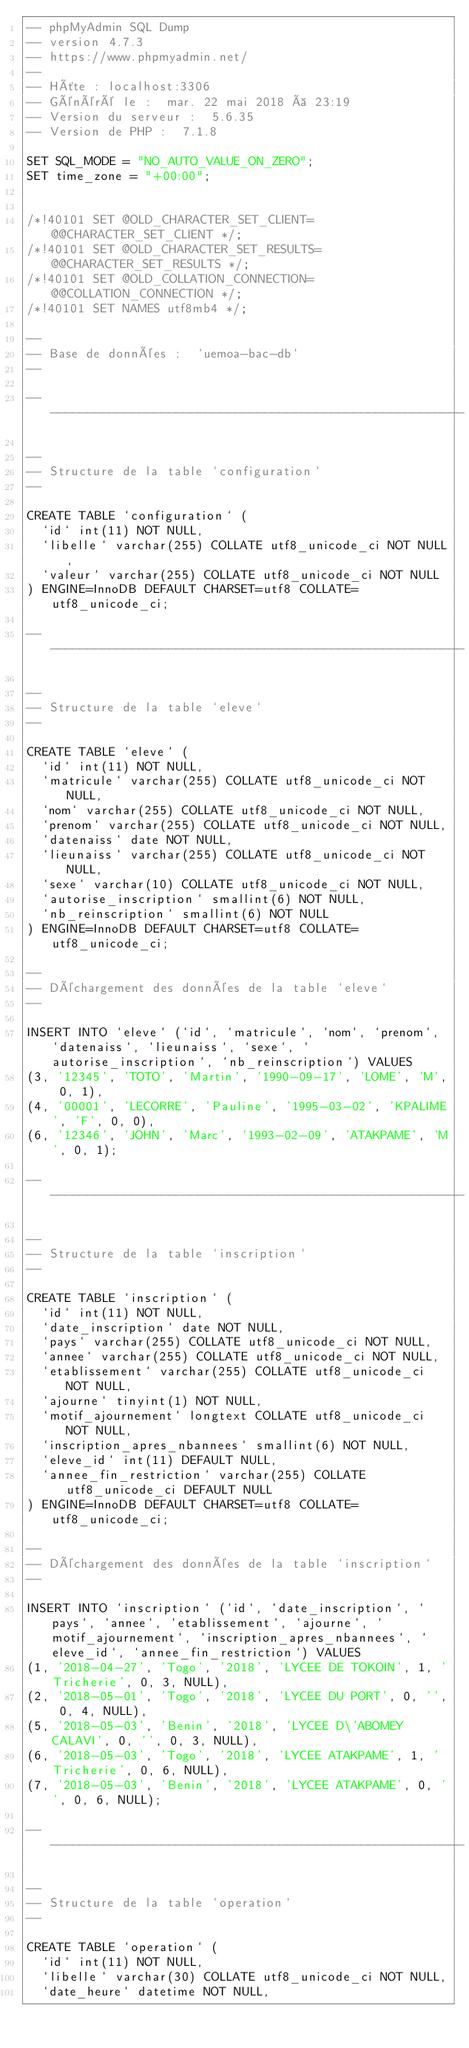<code> <loc_0><loc_0><loc_500><loc_500><_SQL_>-- phpMyAdmin SQL Dump
-- version 4.7.3
-- https://www.phpmyadmin.net/
--
-- Hôte : localhost:3306
-- Généré le :  mar. 22 mai 2018 à 23:19
-- Version du serveur :  5.6.35
-- Version de PHP :  7.1.8

SET SQL_MODE = "NO_AUTO_VALUE_ON_ZERO";
SET time_zone = "+00:00";


/*!40101 SET @OLD_CHARACTER_SET_CLIENT=@@CHARACTER_SET_CLIENT */;
/*!40101 SET @OLD_CHARACTER_SET_RESULTS=@@CHARACTER_SET_RESULTS */;
/*!40101 SET @OLD_COLLATION_CONNECTION=@@COLLATION_CONNECTION */;
/*!40101 SET NAMES utf8mb4 */;

--
-- Base de données :  `uemoa-bac-db`
--

-- --------------------------------------------------------

--
-- Structure de la table `configuration`
--

CREATE TABLE `configuration` (
  `id` int(11) NOT NULL,
  `libelle` varchar(255) COLLATE utf8_unicode_ci NOT NULL,
  `valeur` varchar(255) COLLATE utf8_unicode_ci NOT NULL
) ENGINE=InnoDB DEFAULT CHARSET=utf8 COLLATE=utf8_unicode_ci;

-- --------------------------------------------------------

--
-- Structure de la table `eleve`
--

CREATE TABLE `eleve` (
  `id` int(11) NOT NULL,
  `matricule` varchar(255) COLLATE utf8_unicode_ci NOT NULL,
  `nom` varchar(255) COLLATE utf8_unicode_ci NOT NULL,
  `prenom` varchar(255) COLLATE utf8_unicode_ci NOT NULL,
  `datenaiss` date NOT NULL,
  `lieunaiss` varchar(255) COLLATE utf8_unicode_ci NOT NULL,
  `sexe` varchar(10) COLLATE utf8_unicode_ci NOT NULL,
  `autorise_inscription` smallint(6) NOT NULL,
  `nb_reinscription` smallint(6) NOT NULL
) ENGINE=InnoDB DEFAULT CHARSET=utf8 COLLATE=utf8_unicode_ci;

--
-- Déchargement des données de la table `eleve`
--

INSERT INTO `eleve` (`id`, `matricule`, `nom`, `prenom`, `datenaiss`, `lieunaiss`, `sexe`, `autorise_inscription`, `nb_reinscription`) VALUES
(3, '12345', 'TOTO', 'Martin', '1990-09-17', 'LOME', 'M', 0, 1),
(4, '00001', 'LECORRE', 'Pauline', '1995-03-02', 'KPALIME', 'F', 0, 0),
(6, '12346', 'JOHN', 'Marc', '1993-02-09', 'ATAKPAME', 'M', 0, 1);

-- --------------------------------------------------------

--
-- Structure de la table `inscription`
--

CREATE TABLE `inscription` (
  `id` int(11) NOT NULL,
  `date_inscription` date NOT NULL,
  `pays` varchar(255) COLLATE utf8_unicode_ci NOT NULL,
  `annee` varchar(255) COLLATE utf8_unicode_ci NOT NULL,
  `etablissement` varchar(255) COLLATE utf8_unicode_ci NOT NULL,
  `ajourne` tinyint(1) NOT NULL,
  `motif_ajournement` longtext COLLATE utf8_unicode_ci NOT NULL,
  `inscription_apres_nbannees` smallint(6) NOT NULL,
  `eleve_id` int(11) DEFAULT NULL,
  `annee_fin_restriction` varchar(255) COLLATE utf8_unicode_ci DEFAULT NULL
) ENGINE=InnoDB DEFAULT CHARSET=utf8 COLLATE=utf8_unicode_ci;

--
-- Déchargement des données de la table `inscription`
--

INSERT INTO `inscription` (`id`, `date_inscription`, `pays`, `annee`, `etablissement`, `ajourne`, `motif_ajournement`, `inscription_apres_nbannees`, `eleve_id`, `annee_fin_restriction`) VALUES
(1, '2018-04-27', 'Togo', '2018', 'LYCEE DE TOKOIN', 1, 'Tricherie', 0, 3, NULL),
(2, '2018-05-01', 'Togo', '2018', 'LYCEE DU PORT', 0, '', 0, 4, NULL),
(5, '2018-05-03', 'Benin', '2018', 'LYCEE D\'ABOMEY CALAVI', 0, '', 0, 3, NULL),
(6, '2018-05-03', 'Togo', '2018', 'LYCEE ATAKPAME', 1, 'Tricherie', 0, 6, NULL),
(7, '2018-05-03', 'Benin', '2018', 'LYCEE ATAKPAME', 0, '', 0, 6, NULL);

-- --------------------------------------------------------

--
-- Structure de la table `operation`
--

CREATE TABLE `operation` (
  `id` int(11) NOT NULL,
  `libelle` varchar(30) COLLATE utf8_unicode_ci NOT NULL,
  `date_heure` datetime NOT NULL,</code> 